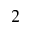<formula> <loc_0><loc_0><loc_500><loc_500>_ { 2 }</formula> 